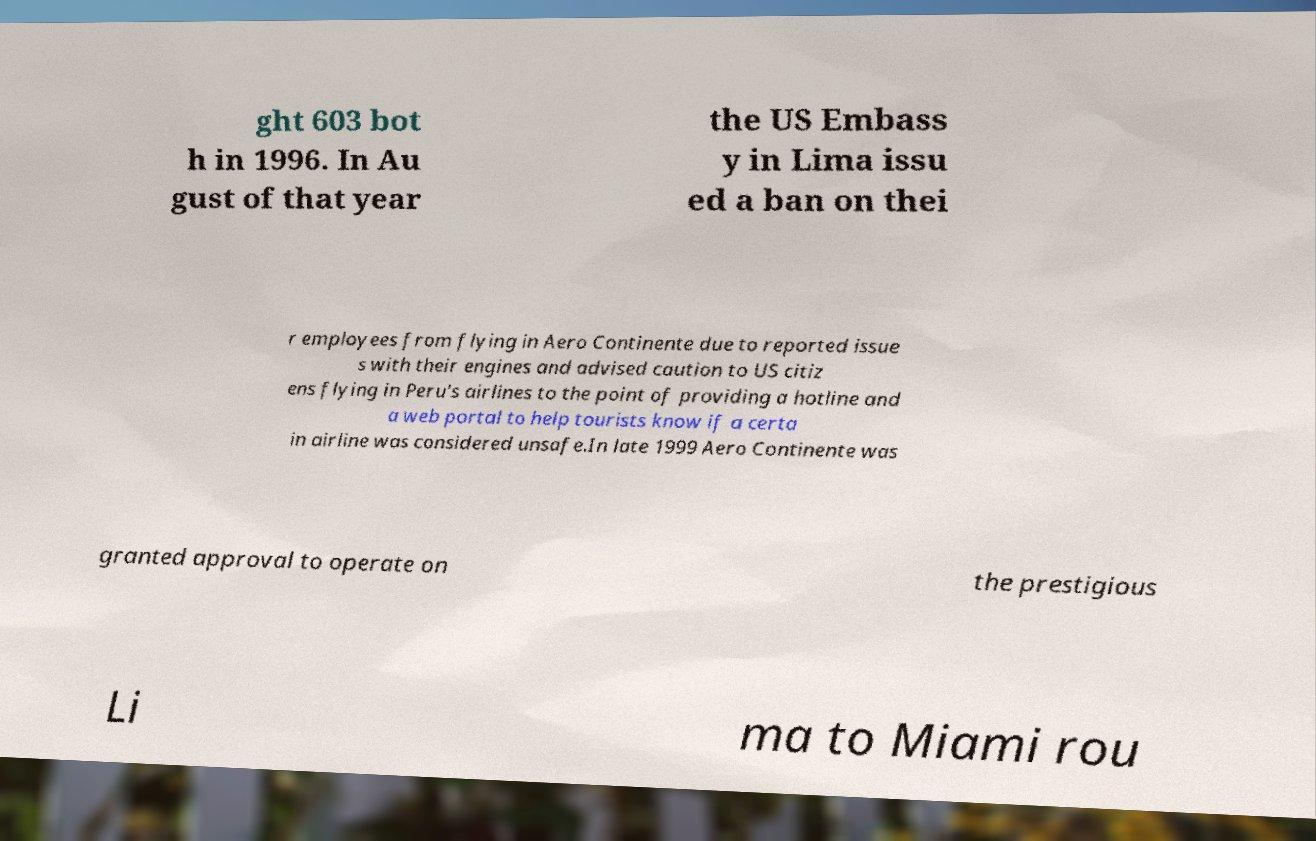I need the written content from this picture converted into text. Can you do that? ght 603 bot h in 1996. In Au gust of that year the US Embass y in Lima issu ed a ban on thei r employees from flying in Aero Continente due to reported issue s with their engines and advised caution to US citiz ens flying in Peru's airlines to the point of providing a hotline and a web portal to help tourists know if a certa in airline was considered unsafe.In late 1999 Aero Continente was granted approval to operate on the prestigious Li ma to Miami rou 